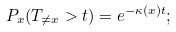<formula> <loc_0><loc_0><loc_500><loc_500>P _ { x } ( T _ { \neq x } > t ) = e ^ { - \kappa ( x ) t } ;</formula> 